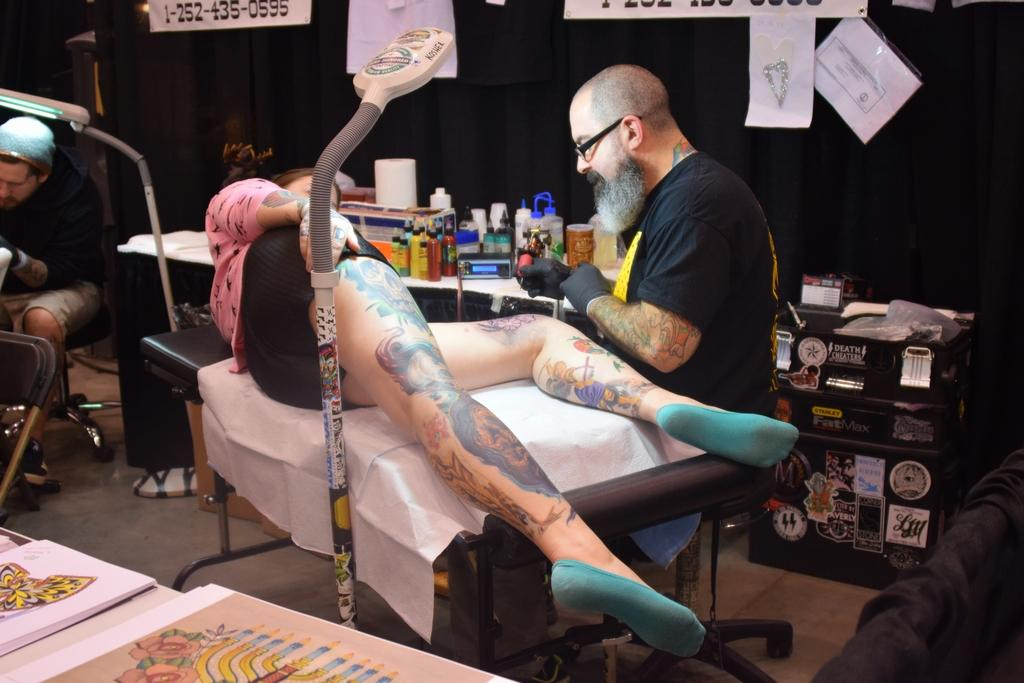Who is the person performing the action in the image? There is a man in the image who is piercing a tattoo. Who is receiving the tattoo in the image? The tattoo is being applied to a woman's leg. Where does the scene take place? The scene takes place in a tattoo store. What type of toothbrush is the man using to apply the tattoo in the image? There is no toothbrush present in the image; the man is using a tattoo machine to apply the tattoo. What kind of humor can be seen in the crib in the image? There is no crib present in the image, and therefore no humor can be observed. 